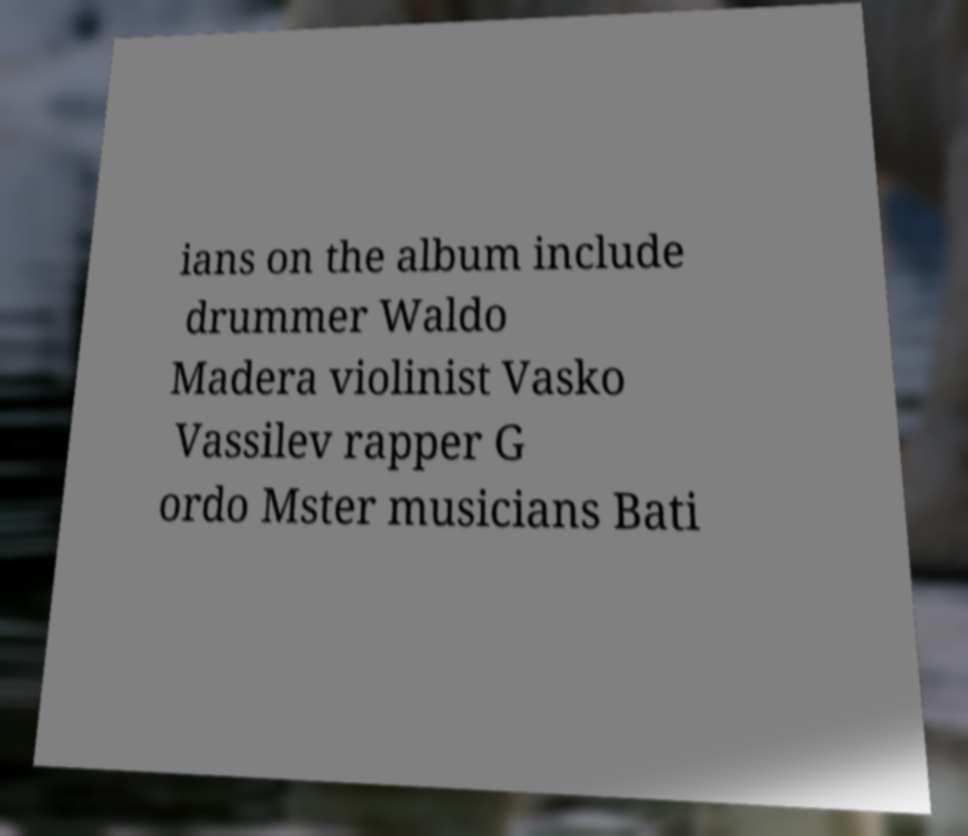Please read and relay the text visible in this image. What does it say? ians on the album include drummer Waldo Madera violinist Vasko Vassilev rapper G ordo Mster musicians Bati 